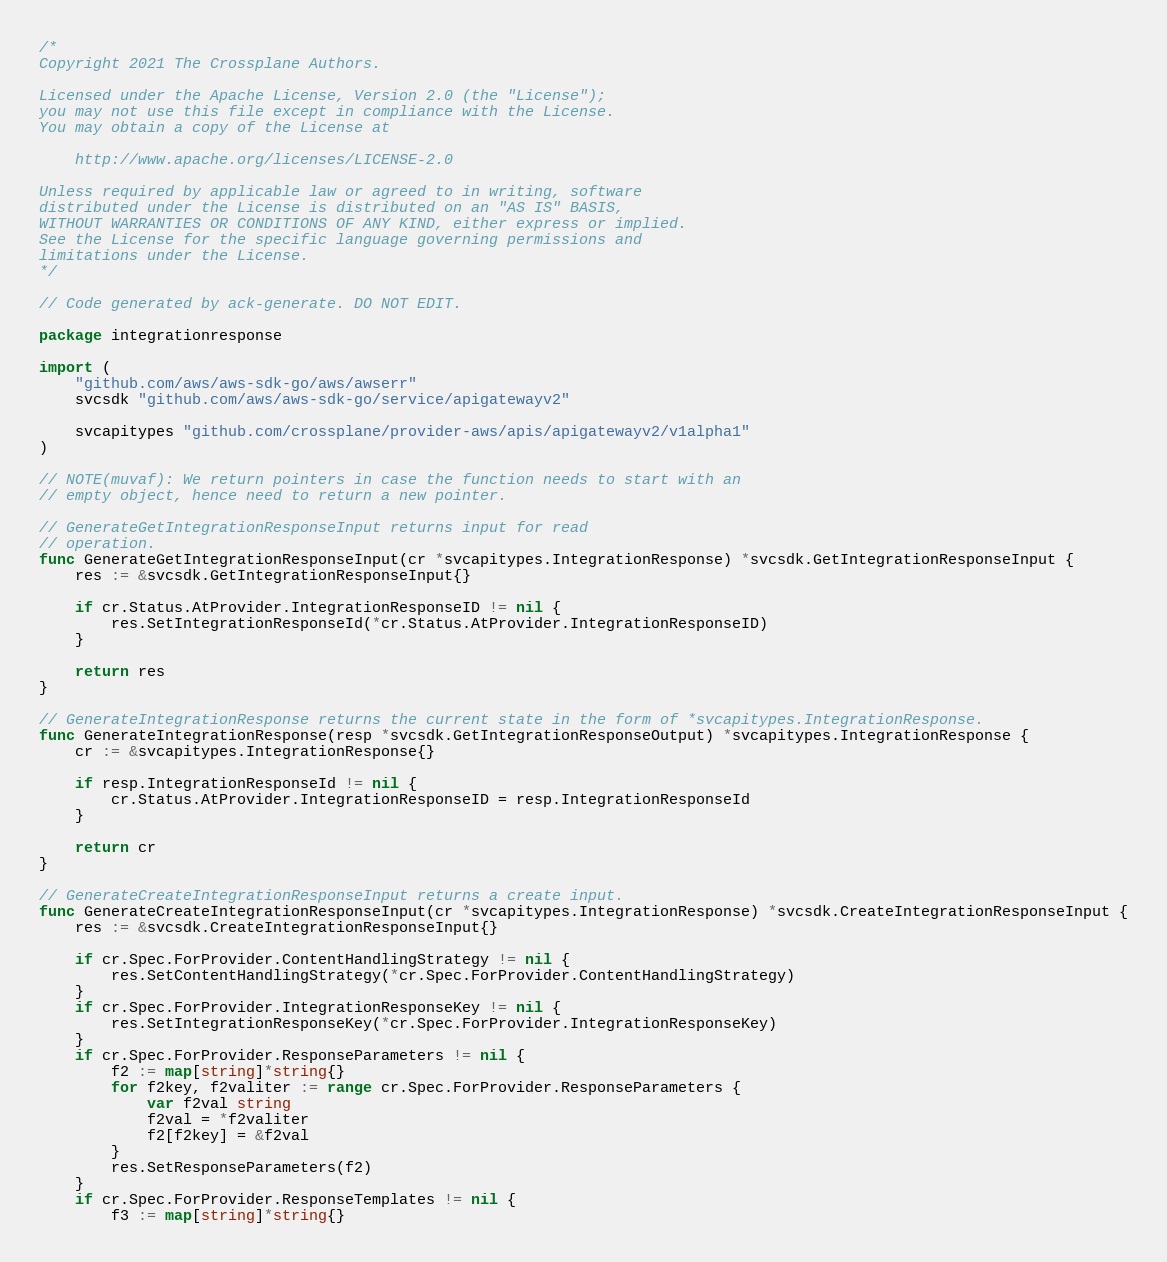Convert code to text. <code><loc_0><loc_0><loc_500><loc_500><_Go_>/*
Copyright 2021 The Crossplane Authors.

Licensed under the Apache License, Version 2.0 (the "License");
you may not use this file except in compliance with the License.
You may obtain a copy of the License at

    http://www.apache.org/licenses/LICENSE-2.0

Unless required by applicable law or agreed to in writing, software
distributed under the License is distributed on an "AS IS" BASIS,
WITHOUT WARRANTIES OR CONDITIONS OF ANY KIND, either express or implied.
See the License for the specific language governing permissions and
limitations under the License.
*/

// Code generated by ack-generate. DO NOT EDIT.

package integrationresponse

import (
	"github.com/aws/aws-sdk-go/aws/awserr"
	svcsdk "github.com/aws/aws-sdk-go/service/apigatewayv2"

	svcapitypes "github.com/crossplane/provider-aws/apis/apigatewayv2/v1alpha1"
)

// NOTE(muvaf): We return pointers in case the function needs to start with an
// empty object, hence need to return a new pointer.

// GenerateGetIntegrationResponseInput returns input for read
// operation.
func GenerateGetIntegrationResponseInput(cr *svcapitypes.IntegrationResponse) *svcsdk.GetIntegrationResponseInput {
	res := &svcsdk.GetIntegrationResponseInput{}

	if cr.Status.AtProvider.IntegrationResponseID != nil {
		res.SetIntegrationResponseId(*cr.Status.AtProvider.IntegrationResponseID)
	}

	return res
}

// GenerateIntegrationResponse returns the current state in the form of *svcapitypes.IntegrationResponse.
func GenerateIntegrationResponse(resp *svcsdk.GetIntegrationResponseOutput) *svcapitypes.IntegrationResponse {
	cr := &svcapitypes.IntegrationResponse{}

	if resp.IntegrationResponseId != nil {
		cr.Status.AtProvider.IntegrationResponseID = resp.IntegrationResponseId
	}

	return cr
}

// GenerateCreateIntegrationResponseInput returns a create input.
func GenerateCreateIntegrationResponseInput(cr *svcapitypes.IntegrationResponse) *svcsdk.CreateIntegrationResponseInput {
	res := &svcsdk.CreateIntegrationResponseInput{}

	if cr.Spec.ForProvider.ContentHandlingStrategy != nil {
		res.SetContentHandlingStrategy(*cr.Spec.ForProvider.ContentHandlingStrategy)
	}
	if cr.Spec.ForProvider.IntegrationResponseKey != nil {
		res.SetIntegrationResponseKey(*cr.Spec.ForProvider.IntegrationResponseKey)
	}
	if cr.Spec.ForProvider.ResponseParameters != nil {
		f2 := map[string]*string{}
		for f2key, f2valiter := range cr.Spec.ForProvider.ResponseParameters {
			var f2val string
			f2val = *f2valiter
			f2[f2key] = &f2val
		}
		res.SetResponseParameters(f2)
	}
	if cr.Spec.ForProvider.ResponseTemplates != nil {
		f3 := map[string]*string{}</code> 